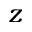<formula> <loc_0><loc_0><loc_500><loc_500>z</formula> 